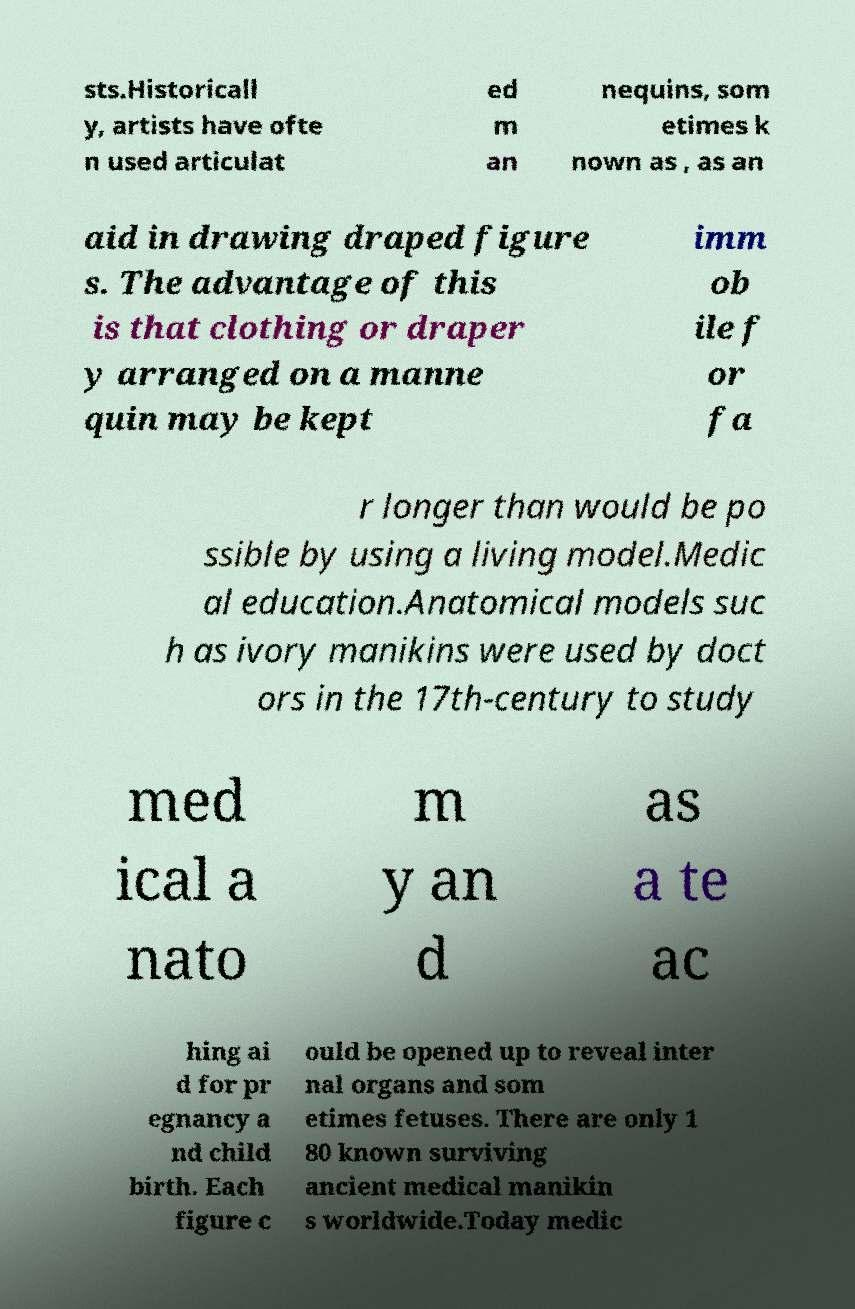For documentation purposes, I need the text within this image transcribed. Could you provide that? sts.Historicall y, artists have ofte n used articulat ed m an nequins, som etimes k nown as , as an aid in drawing draped figure s. The advantage of this is that clothing or draper y arranged on a manne quin may be kept imm ob ile f or fa r longer than would be po ssible by using a living model.Medic al education.Anatomical models suc h as ivory manikins were used by doct ors in the 17th-century to study med ical a nato m y an d as a te ac hing ai d for pr egnancy a nd child birth. Each figure c ould be opened up to reveal inter nal organs and som etimes fetuses. There are only 1 80 known surviving ancient medical manikin s worldwide.Today medic 